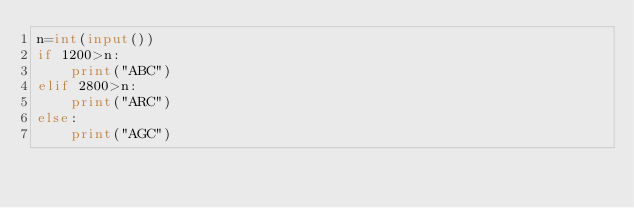<code> <loc_0><loc_0><loc_500><loc_500><_Python_>n=int(input())
if 1200>n:
    print("ABC")
elif 2800>n:
    print("ARC")
else:
    print("AGC")</code> 